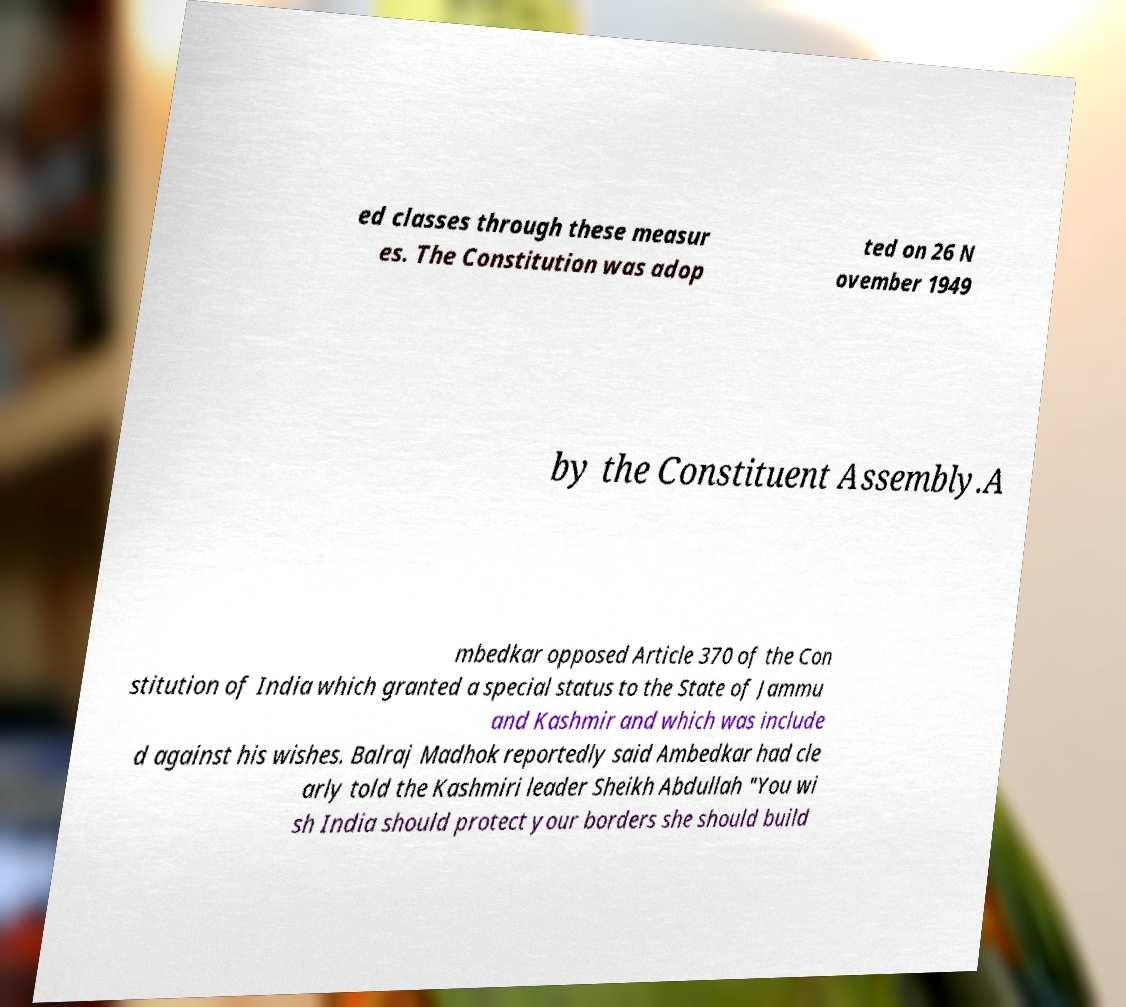Can you read and provide the text displayed in the image?This photo seems to have some interesting text. Can you extract and type it out for me? ed classes through these measur es. The Constitution was adop ted on 26 N ovember 1949 by the Constituent Assembly.A mbedkar opposed Article 370 of the Con stitution of India which granted a special status to the State of Jammu and Kashmir and which was include d against his wishes. Balraj Madhok reportedly said Ambedkar had cle arly told the Kashmiri leader Sheikh Abdullah "You wi sh India should protect your borders she should build 